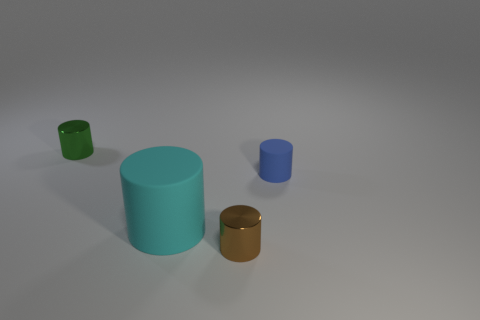What color is the thing that is behind the large matte object and right of the big matte thing?
Provide a succinct answer. Blue. There is a metallic object on the right side of the tiny thing on the left side of the small metallic cylinder in front of the big matte cylinder; what size is it?
Give a very brief answer. Small. What number of objects are tiny objects on the left side of the small rubber cylinder or rubber things left of the blue matte cylinder?
Offer a very short reply. 3. There is a big object; what shape is it?
Provide a short and direct response. Cylinder. What number of other objects are there of the same material as the tiny blue cylinder?
Give a very brief answer. 1. There is a cyan object that is the same shape as the brown shiny object; what size is it?
Keep it short and to the point. Large. What is the material of the small brown cylinder right of the small object that is left of the metallic cylinder in front of the blue cylinder?
Your response must be concise. Metal. Are there any brown cylinders?
Your response must be concise. Yes. The large rubber cylinder has what color?
Make the answer very short. Cyan. What is the color of the other small matte object that is the same shape as the cyan object?
Your answer should be very brief. Blue. 